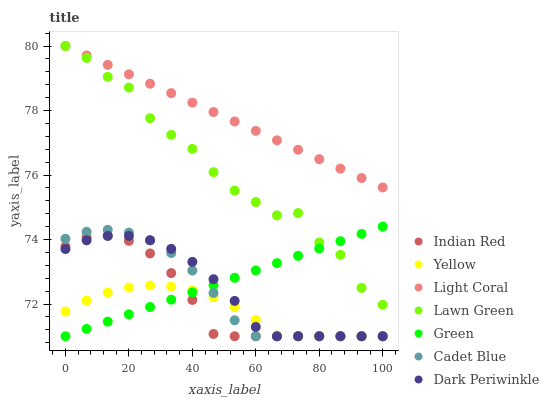Does Yellow have the minimum area under the curve?
Answer yes or no. Yes. Does Light Coral have the maximum area under the curve?
Answer yes or no. Yes. Does Cadet Blue have the minimum area under the curve?
Answer yes or no. No. Does Cadet Blue have the maximum area under the curve?
Answer yes or no. No. Is Green the smoothest?
Answer yes or no. Yes. Is Lawn Green the roughest?
Answer yes or no. Yes. Is Cadet Blue the smoothest?
Answer yes or no. No. Is Cadet Blue the roughest?
Answer yes or no. No. Does Cadet Blue have the lowest value?
Answer yes or no. Yes. Does Light Coral have the lowest value?
Answer yes or no. No. Does Light Coral have the highest value?
Answer yes or no. Yes. Does Cadet Blue have the highest value?
Answer yes or no. No. Is Dark Periwinkle less than Light Coral?
Answer yes or no. Yes. Is Light Coral greater than Green?
Answer yes or no. Yes. Does Cadet Blue intersect Green?
Answer yes or no. Yes. Is Cadet Blue less than Green?
Answer yes or no. No. Is Cadet Blue greater than Green?
Answer yes or no. No. Does Dark Periwinkle intersect Light Coral?
Answer yes or no. No. 